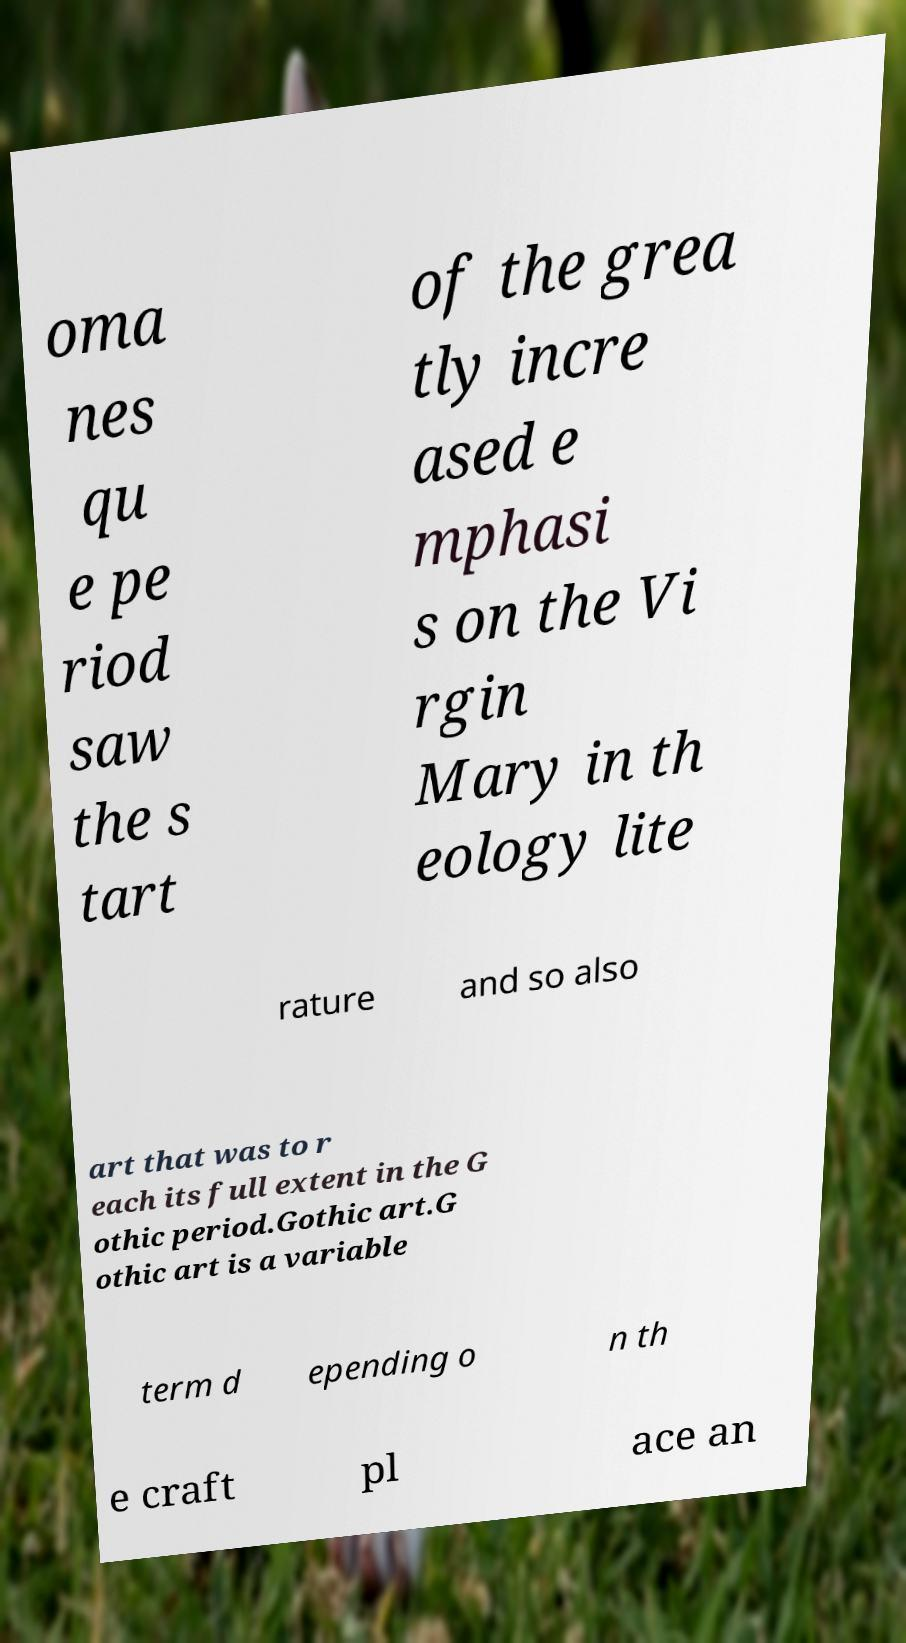For documentation purposes, I need the text within this image transcribed. Could you provide that? oma nes qu e pe riod saw the s tart of the grea tly incre ased e mphasi s on the Vi rgin Mary in th eology lite rature and so also art that was to r each its full extent in the G othic period.Gothic art.G othic art is a variable term d epending o n th e craft pl ace an 